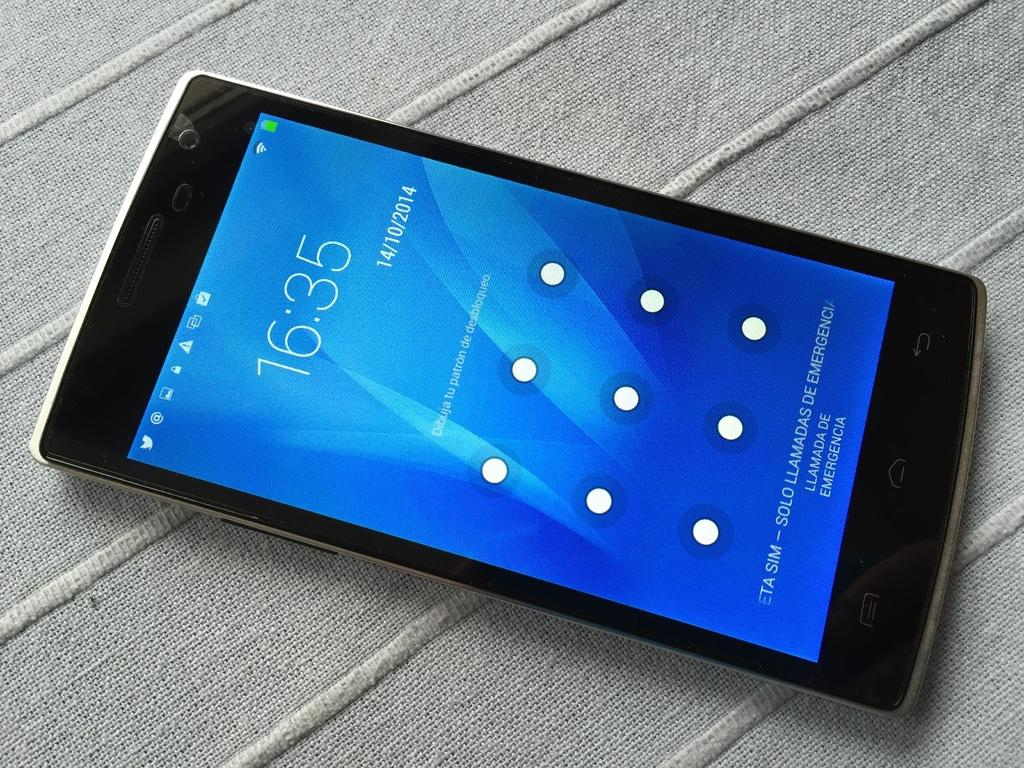<image>
Relay a brief, clear account of the picture shown. A cell phone with a blue screen showing the time of 16:35 